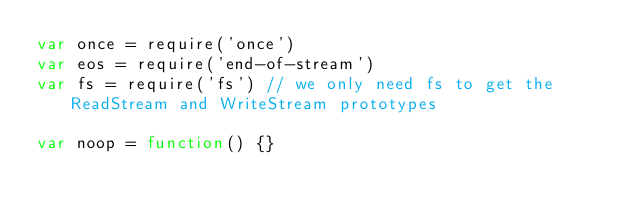Convert code to text. <code><loc_0><loc_0><loc_500><loc_500><_JavaScript_>var once = require('once')
var eos = require('end-of-stream')
var fs = require('fs') // we only need fs to get the ReadStream and WriteStream prototypes

var noop = function() {}</code> 